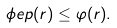Convert formula to latex. <formula><loc_0><loc_0><loc_500><loc_500>\phi e p ( r ) \leq \varphi ( r ) .</formula> 